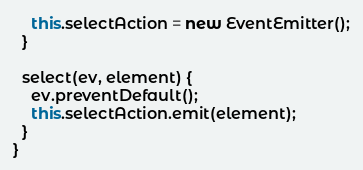Convert code to text. <code><loc_0><loc_0><loc_500><loc_500><_TypeScript_>    this.selectAction = new EventEmitter();
  }

  select(ev, element) {
    ev.preventDefault();
    this.selectAction.emit(element);
  }
}
</code> 